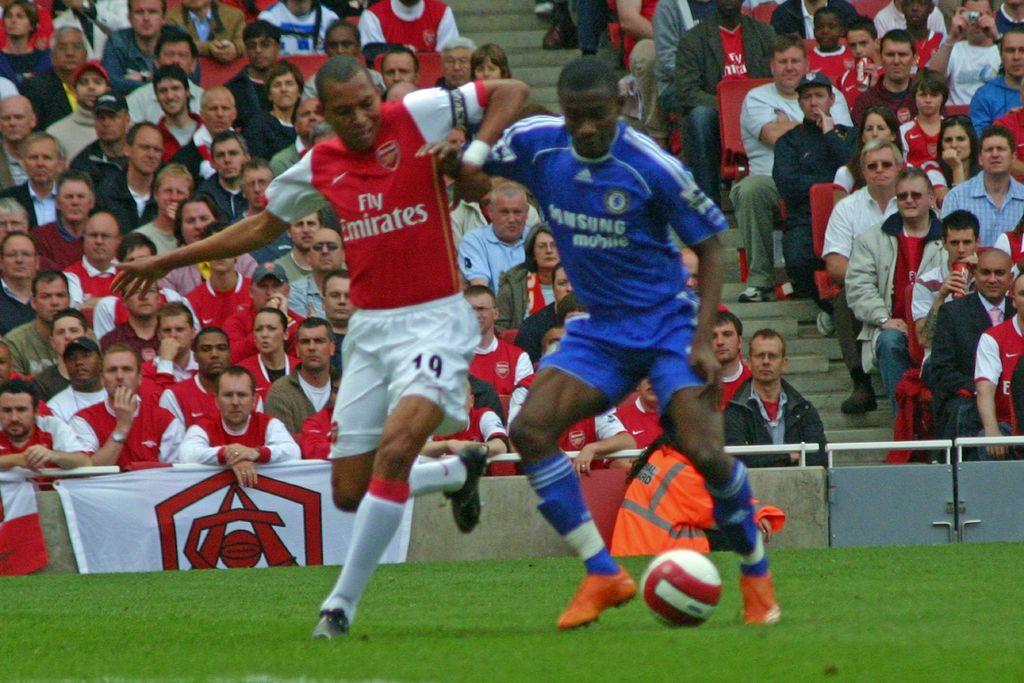Who sponsors the blue team?
Your answer should be compact. Samsung. What is the name of the red team?
Offer a very short reply. Fly emirates. 